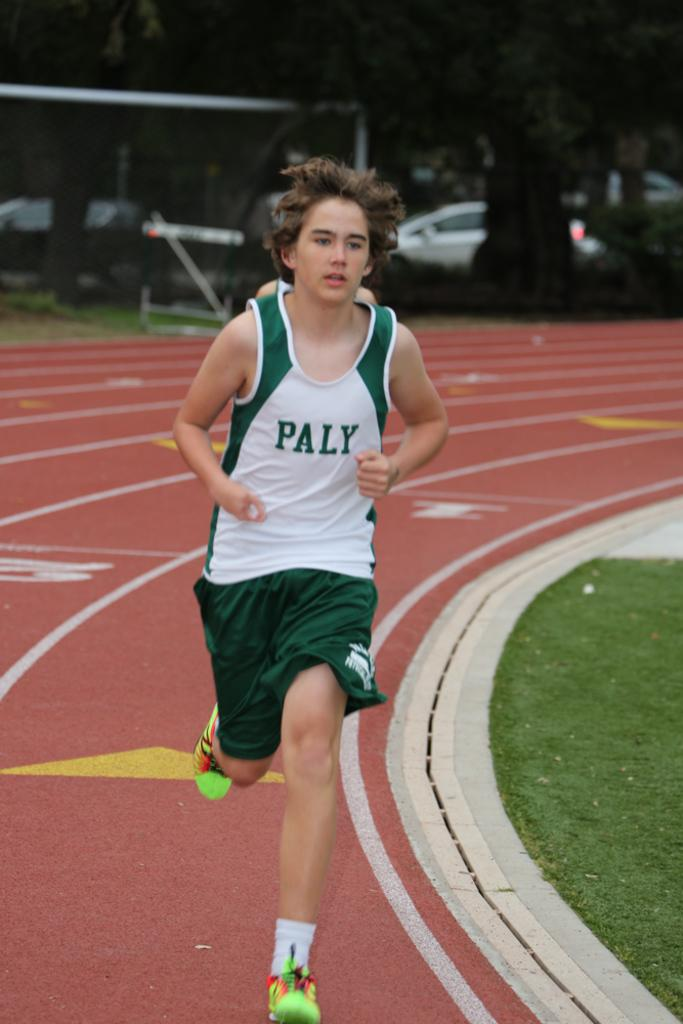<image>
Relay a brief, clear account of the picture shown. A young boy, wearing a green and white PALY jersey, runs on a track. 